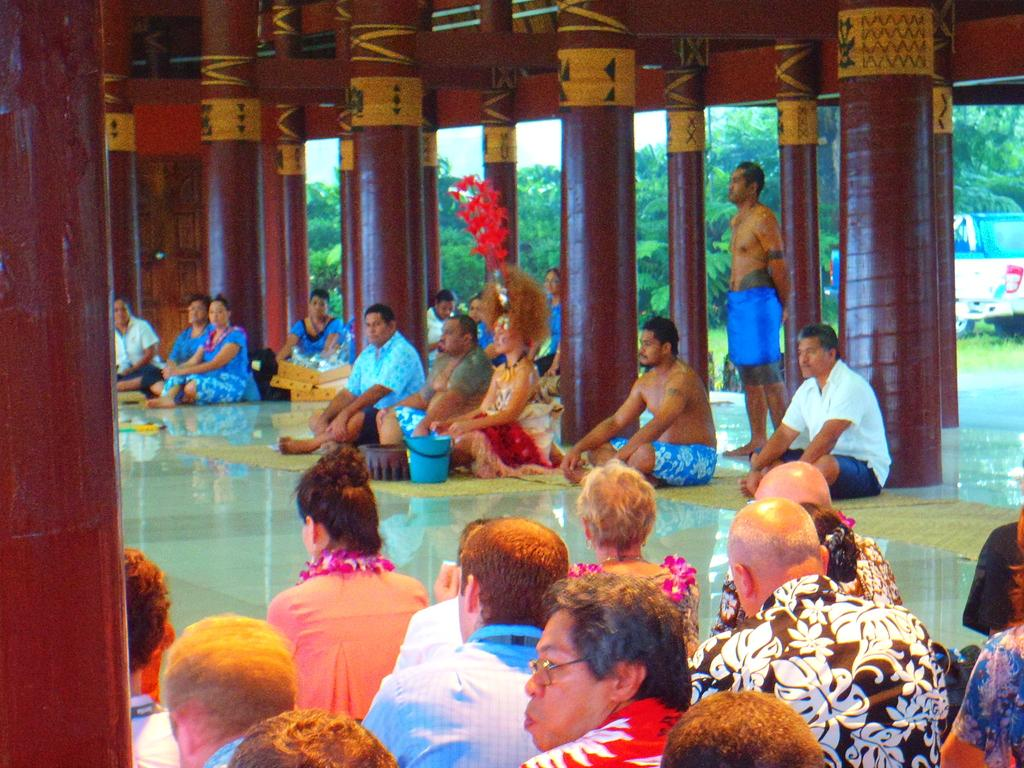What are the people in the image doing? There is a group of people sitting on the floor. Is there anyone standing in the image? Yes, there is a person standing. What architectural features can be seen in the image? Pillars are visible in the image. What else is present in the image besides people? A vehicle and trees are present in the image. What type of salt is being used by the person standing in the image? There is no salt present in the image, and the person standing is not using any. How does the anger of the trees affect the people sitting on the floor? There is no anger present in the image, as trees do not have emotions. 